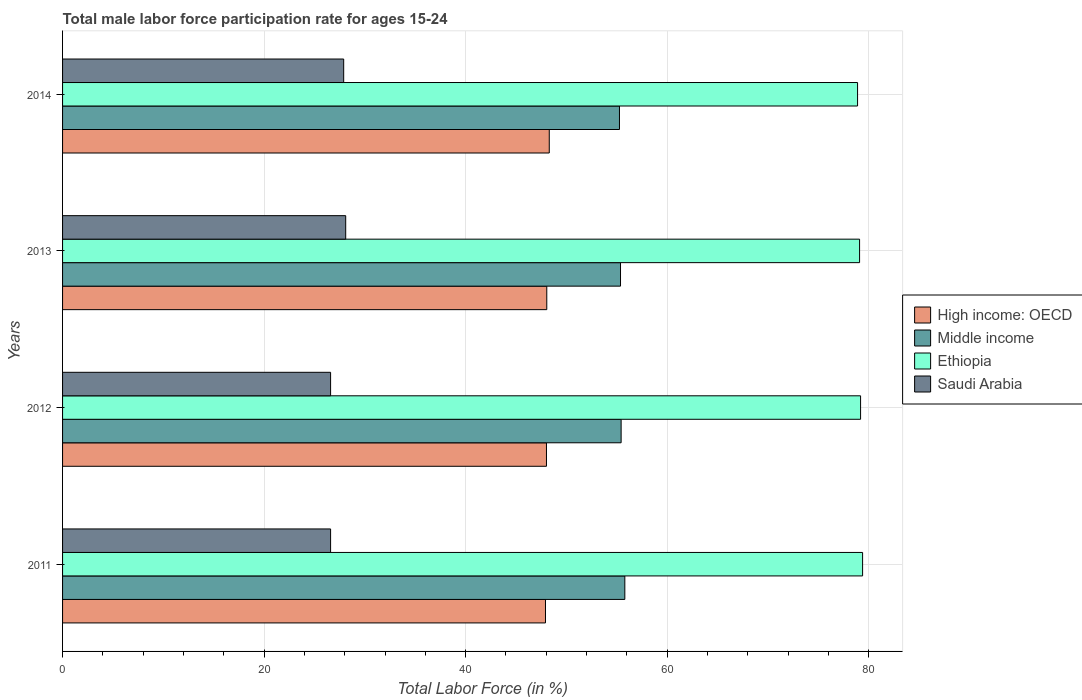How many different coloured bars are there?
Provide a short and direct response. 4. Are the number of bars on each tick of the Y-axis equal?
Provide a short and direct response. Yes. How many bars are there on the 3rd tick from the bottom?
Provide a succinct answer. 4. What is the male labor force participation rate in Ethiopia in 2012?
Offer a terse response. 79.2. Across all years, what is the maximum male labor force participation rate in High income: OECD?
Your answer should be compact. 48.3. Across all years, what is the minimum male labor force participation rate in Middle income?
Keep it short and to the point. 55.27. In which year was the male labor force participation rate in High income: OECD minimum?
Make the answer very short. 2011. What is the total male labor force participation rate in High income: OECD in the graph?
Make the answer very short. 192.31. What is the difference between the male labor force participation rate in Ethiopia in 2013 and that in 2014?
Ensure brevity in your answer.  0.2. What is the difference between the male labor force participation rate in Ethiopia in 2011 and the male labor force participation rate in Saudi Arabia in 2013?
Offer a terse response. 51.3. What is the average male labor force participation rate in Ethiopia per year?
Ensure brevity in your answer.  79.15. In the year 2012, what is the difference between the male labor force participation rate in High income: OECD and male labor force participation rate in Middle income?
Provide a succinct answer. -7.41. In how many years, is the male labor force participation rate in Ethiopia greater than 12 %?
Offer a very short reply. 4. What is the ratio of the male labor force participation rate in Middle income in 2011 to that in 2013?
Provide a short and direct response. 1.01. Is the difference between the male labor force participation rate in High income: OECD in 2011 and 2013 greater than the difference between the male labor force participation rate in Middle income in 2011 and 2013?
Give a very brief answer. No. What is the difference between the highest and the second highest male labor force participation rate in Saudi Arabia?
Offer a very short reply. 0.2. What is the difference between the highest and the lowest male labor force participation rate in Saudi Arabia?
Provide a succinct answer. 1.5. What does the 2nd bar from the top in 2013 represents?
Make the answer very short. Ethiopia. What does the 1st bar from the bottom in 2011 represents?
Your answer should be compact. High income: OECD. Is it the case that in every year, the sum of the male labor force participation rate in Ethiopia and male labor force participation rate in High income: OECD is greater than the male labor force participation rate in Saudi Arabia?
Provide a succinct answer. Yes. Are all the bars in the graph horizontal?
Your answer should be compact. Yes. Does the graph contain any zero values?
Provide a short and direct response. No. Does the graph contain grids?
Give a very brief answer. Yes. Where does the legend appear in the graph?
Your response must be concise. Center right. How are the legend labels stacked?
Offer a terse response. Vertical. What is the title of the graph?
Provide a short and direct response. Total male labor force participation rate for ages 15-24. Does "Cote d'Ivoire" appear as one of the legend labels in the graph?
Your answer should be compact. No. What is the label or title of the X-axis?
Provide a short and direct response. Total Labor Force (in %). What is the label or title of the Y-axis?
Provide a short and direct response. Years. What is the Total Labor Force (in %) in High income: OECD in 2011?
Provide a succinct answer. 47.93. What is the Total Labor Force (in %) in Middle income in 2011?
Provide a succinct answer. 55.8. What is the Total Labor Force (in %) in Ethiopia in 2011?
Your response must be concise. 79.4. What is the Total Labor Force (in %) of Saudi Arabia in 2011?
Your response must be concise. 26.6. What is the Total Labor Force (in %) in High income: OECD in 2012?
Your response must be concise. 48.03. What is the Total Labor Force (in %) in Middle income in 2012?
Provide a succinct answer. 55.43. What is the Total Labor Force (in %) of Ethiopia in 2012?
Keep it short and to the point. 79.2. What is the Total Labor Force (in %) of Saudi Arabia in 2012?
Ensure brevity in your answer.  26.6. What is the Total Labor Force (in %) of High income: OECD in 2013?
Provide a short and direct response. 48.06. What is the Total Labor Force (in %) of Middle income in 2013?
Offer a terse response. 55.37. What is the Total Labor Force (in %) of Ethiopia in 2013?
Keep it short and to the point. 79.1. What is the Total Labor Force (in %) of Saudi Arabia in 2013?
Give a very brief answer. 28.1. What is the Total Labor Force (in %) in High income: OECD in 2014?
Keep it short and to the point. 48.3. What is the Total Labor Force (in %) in Middle income in 2014?
Your answer should be compact. 55.27. What is the Total Labor Force (in %) in Ethiopia in 2014?
Your answer should be compact. 78.9. What is the Total Labor Force (in %) of Saudi Arabia in 2014?
Give a very brief answer. 27.9. Across all years, what is the maximum Total Labor Force (in %) in High income: OECD?
Give a very brief answer. 48.3. Across all years, what is the maximum Total Labor Force (in %) in Middle income?
Give a very brief answer. 55.8. Across all years, what is the maximum Total Labor Force (in %) in Ethiopia?
Make the answer very short. 79.4. Across all years, what is the maximum Total Labor Force (in %) of Saudi Arabia?
Provide a short and direct response. 28.1. Across all years, what is the minimum Total Labor Force (in %) in High income: OECD?
Make the answer very short. 47.93. Across all years, what is the minimum Total Labor Force (in %) of Middle income?
Provide a succinct answer. 55.27. Across all years, what is the minimum Total Labor Force (in %) of Ethiopia?
Provide a succinct answer. 78.9. Across all years, what is the minimum Total Labor Force (in %) of Saudi Arabia?
Offer a terse response. 26.6. What is the total Total Labor Force (in %) in High income: OECD in the graph?
Make the answer very short. 192.31. What is the total Total Labor Force (in %) in Middle income in the graph?
Provide a short and direct response. 221.88. What is the total Total Labor Force (in %) of Ethiopia in the graph?
Give a very brief answer. 316.6. What is the total Total Labor Force (in %) of Saudi Arabia in the graph?
Give a very brief answer. 109.2. What is the difference between the Total Labor Force (in %) of High income: OECD in 2011 and that in 2012?
Offer a terse response. -0.1. What is the difference between the Total Labor Force (in %) of Middle income in 2011 and that in 2012?
Your answer should be very brief. 0.37. What is the difference between the Total Labor Force (in %) in High income: OECD in 2011 and that in 2013?
Provide a short and direct response. -0.13. What is the difference between the Total Labor Force (in %) of Middle income in 2011 and that in 2013?
Your answer should be very brief. 0.43. What is the difference between the Total Labor Force (in %) in Ethiopia in 2011 and that in 2013?
Provide a succinct answer. 0.3. What is the difference between the Total Labor Force (in %) in High income: OECD in 2011 and that in 2014?
Offer a terse response. -0.37. What is the difference between the Total Labor Force (in %) in Middle income in 2011 and that in 2014?
Your answer should be very brief. 0.53. What is the difference between the Total Labor Force (in %) of Ethiopia in 2011 and that in 2014?
Keep it short and to the point. 0.5. What is the difference between the Total Labor Force (in %) in High income: OECD in 2012 and that in 2013?
Offer a very short reply. -0.03. What is the difference between the Total Labor Force (in %) in Middle income in 2012 and that in 2013?
Provide a short and direct response. 0.06. What is the difference between the Total Labor Force (in %) in Ethiopia in 2012 and that in 2013?
Your answer should be very brief. 0.1. What is the difference between the Total Labor Force (in %) of High income: OECD in 2012 and that in 2014?
Offer a terse response. -0.28. What is the difference between the Total Labor Force (in %) of Middle income in 2012 and that in 2014?
Give a very brief answer. 0.16. What is the difference between the Total Labor Force (in %) in Ethiopia in 2012 and that in 2014?
Your answer should be compact. 0.3. What is the difference between the Total Labor Force (in %) in Saudi Arabia in 2012 and that in 2014?
Ensure brevity in your answer.  -1.3. What is the difference between the Total Labor Force (in %) in High income: OECD in 2013 and that in 2014?
Your response must be concise. -0.25. What is the difference between the Total Labor Force (in %) in Middle income in 2013 and that in 2014?
Provide a succinct answer. 0.1. What is the difference between the Total Labor Force (in %) of Ethiopia in 2013 and that in 2014?
Offer a very short reply. 0.2. What is the difference between the Total Labor Force (in %) of Saudi Arabia in 2013 and that in 2014?
Give a very brief answer. 0.2. What is the difference between the Total Labor Force (in %) of High income: OECD in 2011 and the Total Labor Force (in %) of Middle income in 2012?
Your answer should be compact. -7.51. What is the difference between the Total Labor Force (in %) of High income: OECD in 2011 and the Total Labor Force (in %) of Ethiopia in 2012?
Offer a very short reply. -31.27. What is the difference between the Total Labor Force (in %) in High income: OECD in 2011 and the Total Labor Force (in %) in Saudi Arabia in 2012?
Your answer should be compact. 21.33. What is the difference between the Total Labor Force (in %) of Middle income in 2011 and the Total Labor Force (in %) of Ethiopia in 2012?
Your response must be concise. -23.4. What is the difference between the Total Labor Force (in %) in Middle income in 2011 and the Total Labor Force (in %) in Saudi Arabia in 2012?
Your answer should be compact. 29.2. What is the difference between the Total Labor Force (in %) of Ethiopia in 2011 and the Total Labor Force (in %) of Saudi Arabia in 2012?
Make the answer very short. 52.8. What is the difference between the Total Labor Force (in %) of High income: OECD in 2011 and the Total Labor Force (in %) of Middle income in 2013?
Offer a very short reply. -7.45. What is the difference between the Total Labor Force (in %) of High income: OECD in 2011 and the Total Labor Force (in %) of Ethiopia in 2013?
Your response must be concise. -31.17. What is the difference between the Total Labor Force (in %) in High income: OECD in 2011 and the Total Labor Force (in %) in Saudi Arabia in 2013?
Provide a short and direct response. 19.83. What is the difference between the Total Labor Force (in %) in Middle income in 2011 and the Total Labor Force (in %) in Ethiopia in 2013?
Make the answer very short. -23.3. What is the difference between the Total Labor Force (in %) of Middle income in 2011 and the Total Labor Force (in %) of Saudi Arabia in 2013?
Your answer should be very brief. 27.7. What is the difference between the Total Labor Force (in %) of Ethiopia in 2011 and the Total Labor Force (in %) of Saudi Arabia in 2013?
Provide a succinct answer. 51.3. What is the difference between the Total Labor Force (in %) in High income: OECD in 2011 and the Total Labor Force (in %) in Middle income in 2014?
Keep it short and to the point. -7.34. What is the difference between the Total Labor Force (in %) in High income: OECD in 2011 and the Total Labor Force (in %) in Ethiopia in 2014?
Ensure brevity in your answer.  -30.97. What is the difference between the Total Labor Force (in %) of High income: OECD in 2011 and the Total Labor Force (in %) of Saudi Arabia in 2014?
Make the answer very short. 20.03. What is the difference between the Total Labor Force (in %) in Middle income in 2011 and the Total Labor Force (in %) in Ethiopia in 2014?
Your answer should be compact. -23.1. What is the difference between the Total Labor Force (in %) in Middle income in 2011 and the Total Labor Force (in %) in Saudi Arabia in 2014?
Ensure brevity in your answer.  27.9. What is the difference between the Total Labor Force (in %) of Ethiopia in 2011 and the Total Labor Force (in %) of Saudi Arabia in 2014?
Give a very brief answer. 51.5. What is the difference between the Total Labor Force (in %) of High income: OECD in 2012 and the Total Labor Force (in %) of Middle income in 2013?
Offer a very short reply. -7.35. What is the difference between the Total Labor Force (in %) in High income: OECD in 2012 and the Total Labor Force (in %) in Ethiopia in 2013?
Your response must be concise. -31.07. What is the difference between the Total Labor Force (in %) of High income: OECD in 2012 and the Total Labor Force (in %) of Saudi Arabia in 2013?
Keep it short and to the point. 19.93. What is the difference between the Total Labor Force (in %) in Middle income in 2012 and the Total Labor Force (in %) in Ethiopia in 2013?
Provide a succinct answer. -23.67. What is the difference between the Total Labor Force (in %) in Middle income in 2012 and the Total Labor Force (in %) in Saudi Arabia in 2013?
Keep it short and to the point. 27.33. What is the difference between the Total Labor Force (in %) of Ethiopia in 2012 and the Total Labor Force (in %) of Saudi Arabia in 2013?
Your response must be concise. 51.1. What is the difference between the Total Labor Force (in %) of High income: OECD in 2012 and the Total Labor Force (in %) of Middle income in 2014?
Provide a succinct answer. -7.24. What is the difference between the Total Labor Force (in %) in High income: OECD in 2012 and the Total Labor Force (in %) in Ethiopia in 2014?
Your answer should be compact. -30.87. What is the difference between the Total Labor Force (in %) in High income: OECD in 2012 and the Total Labor Force (in %) in Saudi Arabia in 2014?
Your response must be concise. 20.13. What is the difference between the Total Labor Force (in %) of Middle income in 2012 and the Total Labor Force (in %) of Ethiopia in 2014?
Your response must be concise. -23.47. What is the difference between the Total Labor Force (in %) of Middle income in 2012 and the Total Labor Force (in %) of Saudi Arabia in 2014?
Offer a terse response. 27.53. What is the difference between the Total Labor Force (in %) in Ethiopia in 2012 and the Total Labor Force (in %) in Saudi Arabia in 2014?
Give a very brief answer. 51.3. What is the difference between the Total Labor Force (in %) in High income: OECD in 2013 and the Total Labor Force (in %) in Middle income in 2014?
Provide a succinct answer. -7.21. What is the difference between the Total Labor Force (in %) in High income: OECD in 2013 and the Total Labor Force (in %) in Ethiopia in 2014?
Provide a short and direct response. -30.84. What is the difference between the Total Labor Force (in %) of High income: OECD in 2013 and the Total Labor Force (in %) of Saudi Arabia in 2014?
Your answer should be very brief. 20.16. What is the difference between the Total Labor Force (in %) of Middle income in 2013 and the Total Labor Force (in %) of Ethiopia in 2014?
Ensure brevity in your answer.  -23.53. What is the difference between the Total Labor Force (in %) in Middle income in 2013 and the Total Labor Force (in %) in Saudi Arabia in 2014?
Your answer should be very brief. 27.47. What is the difference between the Total Labor Force (in %) of Ethiopia in 2013 and the Total Labor Force (in %) of Saudi Arabia in 2014?
Your response must be concise. 51.2. What is the average Total Labor Force (in %) in High income: OECD per year?
Keep it short and to the point. 48.08. What is the average Total Labor Force (in %) of Middle income per year?
Your response must be concise. 55.47. What is the average Total Labor Force (in %) in Ethiopia per year?
Your answer should be compact. 79.15. What is the average Total Labor Force (in %) in Saudi Arabia per year?
Your answer should be very brief. 27.3. In the year 2011, what is the difference between the Total Labor Force (in %) of High income: OECD and Total Labor Force (in %) of Middle income?
Make the answer very short. -7.87. In the year 2011, what is the difference between the Total Labor Force (in %) in High income: OECD and Total Labor Force (in %) in Ethiopia?
Ensure brevity in your answer.  -31.47. In the year 2011, what is the difference between the Total Labor Force (in %) in High income: OECD and Total Labor Force (in %) in Saudi Arabia?
Provide a succinct answer. 21.33. In the year 2011, what is the difference between the Total Labor Force (in %) in Middle income and Total Labor Force (in %) in Ethiopia?
Provide a short and direct response. -23.6. In the year 2011, what is the difference between the Total Labor Force (in %) in Middle income and Total Labor Force (in %) in Saudi Arabia?
Your answer should be very brief. 29.2. In the year 2011, what is the difference between the Total Labor Force (in %) in Ethiopia and Total Labor Force (in %) in Saudi Arabia?
Keep it short and to the point. 52.8. In the year 2012, what is the difference between the Total Labor Force (in %) in High income: OECD and Total Labor Force (in %) in Middle income?
Provide a succinct answer. -7.41. In the year 2012, what is the difference between the Total Labor Force (in %) in High income: OECD and Total Labor Force (in %) in Ethiopia?
Your answer should be compact. -31.17. In the year 2012, what is the difference between the Total Labor Force (in %) of High income: OECD and Total Labor Force (in %) of Saudi Arabia?
Make the answer very short. 21.43. In the year 2012, what is the difference between the Total Labor Force (in %) of Middle income and Total Labor Force (in %) of Ethiopia?
Your answer should be compact. -23.77. In the year 2012, what is the difference between the Total Labor Force (in %) of Middle income and Total Labor Force (in %) of Saudi Arabia?
Offer a terse response. 28.83. In the year 2012, what is the difference between the Total Labor Force (in %) of Ethiopia and Total Labor Force (in %) of Saudi Arabia?
Provide a short and direct response. 52.6. In the year 2013, what is the difference between the Total Labor Force (in %) of High income: OECD and Total Labor Force (in %) of Middle income?
Provide a succinct answer. -7.32. In the year 2013, what is the difference between the Total Labor Force (in %) in High income: OECD and Total Labor Force (in %) in Ethiopia?
Offer a terse response. -31.04. In the year 2013, what is the difference between the Total Labor Force (in %) of High income: OECD and Total Labor Force (in %) of Saudi Arabia?
Provide a succinct answer. 19.96. In the year 2013, what is the difference between the Total Labor Force (in %) of Middle income and Total Labor Force (in %) of Ethiopia?
Your response must be concise. -23.73. In the year 2013, what is the difference between the Total Labor Force (in %) in Middle income and Total Labor Force (in %) in Saudi Arabia?
Offer a terse response. 27.27. In the year 2014, what is the difference between the Total Labor Force (in %) of High income: OECD and Total Labor Force (in %) of Middle income?
Your answer should be very brief. -6.97. In the year 2014, what is the difference between the Total Labor Force (in %) in High income: OECD and Total Labor Force (in %) in Ethiopia?
Your answer should be very brief. -30.6. In the year 2014, what is the difference between the Total Labor Force (in %) in High income: OECD and Total Labor Force (in %) in Saudi Arabia?
Make the answer very short. 20.4. In the year 2014, what is the difference between the Total Labor Force (in %) in Middle income and Total Labor Force (in %) in Ethiopia?
Offer a very short reply. -23.63. In the year 2014, what is the difference between the Total Labor Force (in %) in Middle income and Total Labor Force (in %) in Saudi Arabia?
Offer a very short reply. 27.37. What is the ratio of the Total Labor Force (in %) of Middle income in 2011 to that in 2012?
Offer a terse response. 1.01. What is the ratio of the Total Labor Force (in %) in Ethiopia in 2011 to that in 2012?
Offer a very short reply. 1. What is the ratio of the Total Labor Force (in %) of Middle income in 2011 to that in 2013?
Offer a very short reply. 1.01. What is the ratio of the Total Labor Force (in %) of Ethiopia in 2011 to that in 2013?
Keep it short and to the point. 1. What is the ratio of the Total Labor Force (in %) in Saudi Arabia in 2011 to that in 2013?
Give a very brief answer. 0.95. What is the ratio of the Total Labor Force (in %) in High income: OECD in 2011 to that in 2014?
Ensure brevity in your answer.  0.99. What is the ratio of the Total Labor Force (in %) of Middle income in 2011 to that in 2014?
Keep it short and to the point. 1.01. What is the ratio of the Total Labor Force (in %) of Ethiopia in 2011 to that in 2014?
Keep it short and to the point. 1.01. What is the ratio of the Total Labor Force (in %) in Saudi Arabia in 2011 to that in 2014?
Offer a terse response. 0.95. What is the ratio of the Total Labor Force (in %) of Middle income in 2012 to that in 2013?
Offer a terse response. 1. What is the ratio of the Total Labor Force (in %) in Ethiopia in 2012 to that in 2013?
Make the answer very short. 1. What is the ratio of the Total Labor Force (in %) in Saudi Arabia in 2012 to that in 2013?
Offer a very short reply. 0.95. What is the ratio of the Total Labor Force (in %) in Middle income in 2012 to that in 2014?
Your answer should be very brief. 1. What is the ratio of the Total Labor Force (in %) of Ethiopia in 2012 to that in 2014?
Make the answer very short. 1. What is the ratio of the Total Labor Force (in %) in Saudi Arabia in 2012 to that in 2014?
Keep it short and to the point. 0.95. What is the ratio of the Total Labor Force (in %) of High income: OECD in 2013 to that in 2014?
Ensure brevity in your answer.  0.99. What is the ratio of the Total Labor Force (in %) in Ethiopia in 2013 to that in 2014?
Provide a short and direct response. 1. What is the ratio of the Total Labor Force (in %) in Saudi Arabia in 2013 to that in 2014?
Offer a very short reply. 1.01. What is the difference between the highest and the second highest Total Labor Force (in %) of High income: OECD?
Give a very brief answer. 0.25. What is the difference between the highest and the second highest Total Labor Force (in %) in Middle income?
Offer a very short reply. 0.37. What is the difference between the highest and the second highest Total Labor Force (in %) in Ethiopia?
Offer a very short reply. 0.2. What is the difference between the highest and the second highest Total Labor Force (in %) of Saudi Arabia?
Ensure brevity in your answer.  0.2. What is the difference between the highest and the lowest Total Labor Force (in %) in High income: OECD?
Provide a succinct answer. 0.37. What is the difference between the highest and the lowest Total Labor Force (in %) in Middle income?
Offer a terse response. 0.53. What is the difference between the highest and the lowest Total Labor Force (in %) of Saudi Arabia?
Make the answer very short. 1.5. 